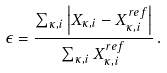<formula> <loc_0><loc_0><loc_500><loc_500>\epsilon = \frac { \sum _ { \kappa , i } \left | X _ { \kappa , i } - X ^ { r e f } _ { \kappa , i } \right | } { \sum _ { \kappa , i } X ^ { r e f } _ { \kappa , i } } \, .</formula> 